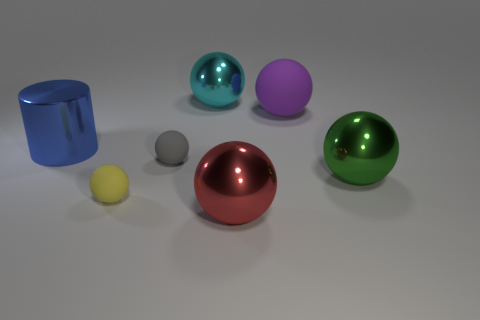Subtract 4 spheres. How many spheres are left? 2 Subtract all purple balls. How many balls are left? 5 Subtract all red balls. How many balls are left? 5 Subtract all blue balls. Subtract all red cylinders. How many balls are left? 6 Add 1 small gray spheres. How many objects exist? 8 Subtract all balls. How many objects are left? 1 Add 3 large matte spheres. How many large matte spheres exist? 4 Subtract 0 brown balls. How many objects are left? 7 Subtract all large red objects. Subtract all big purple rubber balls. How many objects are left? 5 Add 6 red balls. How many red balls are left? 7 